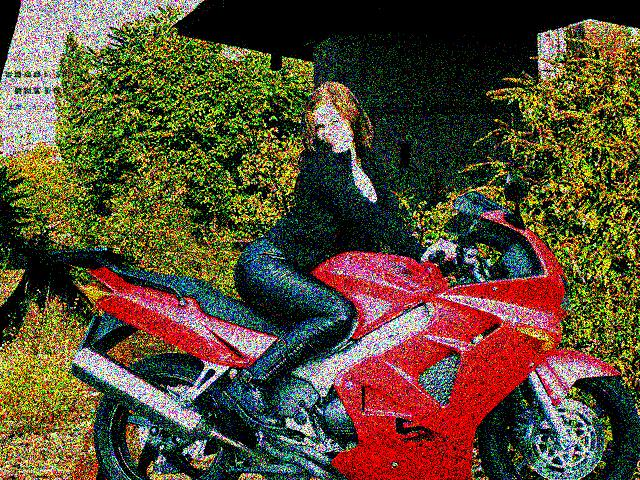What is the difficulty in seeing the faces of the people?
A. Blurry focus
B. Pixelation
C. Too many noise points
D. Low lighting conditions
Answer with the option's letter from the given choices directly. The difficulty in seeing the faces of the people in the image primarily stems from pixelation (B). The degradation of image clarity suggests the photos have either been enlarged beyond the resolution's capacity or have been subject to a low-quality capture process. As a result, the details of the faces are not discernible. 